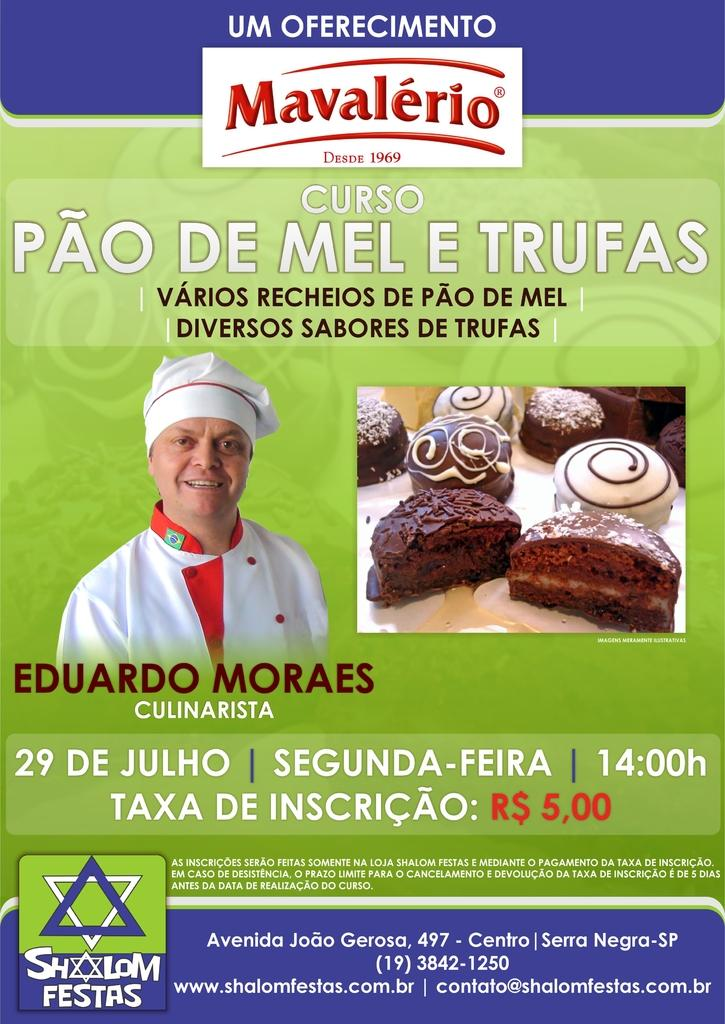What is the person in the image wearing? The person in the image is wearing a white and red color dress. What can be seen on the table in the image? There are cakes in the image. What is written on the cakes? There is writing on the cakes. What colors are present in the background of the image? The background of the image includes green, blue, and white colors. What type of locket is the person wearing in the image? There is no locket visible on the person in the image. What time of day is it in the image, based on the hour? The provided facts do not mention the time of day or any specific hour, so it cannot be determined from the image. 